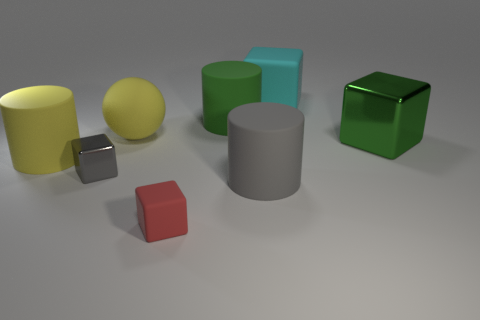What is the material of the cyan block?
Provide a short and direct response. Rubber. There is a cube behind the metal thing that is to the right of the cyan matte cube; what is its size?
Give a very brief answer. Large. There is another large metal thing that is the same shape as the red thing; what color is it?
Provide a short and direct response. Green. What is the material of the small gray object left of the thing right of the big cyan block?
Keep it short and to the point. Metal. There is a large green thing to the left of the cyan thing; is its shape the same as the gray thing that is right of the big green matte cylinder?
Your answer should be compact. Yes. There is a rubber object that is both to the right of the red matte cube and in front of the green matte cylinder; what is its size?
Give a very brief answer. Large. What number of other things are the same color as the small matte cube?
Ensure brevity in your answer.  0. Are the cylinder that is on the left side of the green rubber object and the large yellow sphere made of the same material?
Your answer should be compact. Yes. Is there anything else that has the same size as the gray cube?
Your answer should be compact. Yes. Are there fewer matte spheres right of the red matte cube than large gray things that are behind the big green shiny block?
Provide a short and direct response. No. 